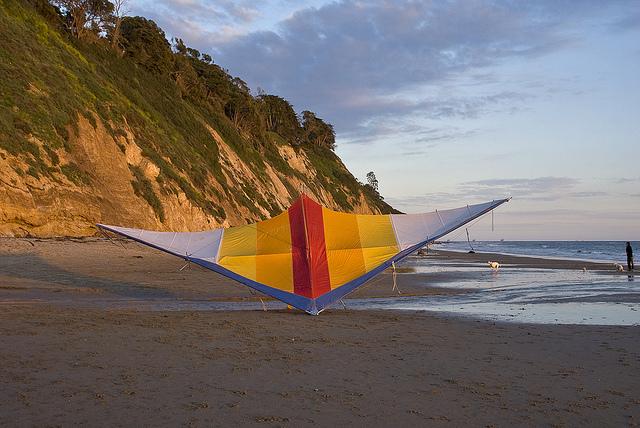What animals are visible?
Answer briefly. Dog. What sport is the person participating in?
Quick response, please. Hang gliding. Will there be sand on this kite?
Quick response, please. Yes. Why isn't the kite in the air?
Answer briefly. Landing. What is in the background?
Write a very short answer. Water. 